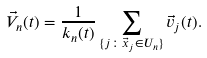Convert formula to latex. <formula><loc_0><loc_0><loc_500><loc_500>\vec { V } _ { n } ( t ) = \frac { 1 } { k _ { n } ( t ) } \sum _ { \{ j \colon \vec { x } _ { j } \in U _ { n } \} } \vec { v } _ { j } ( t ) .</formula> 